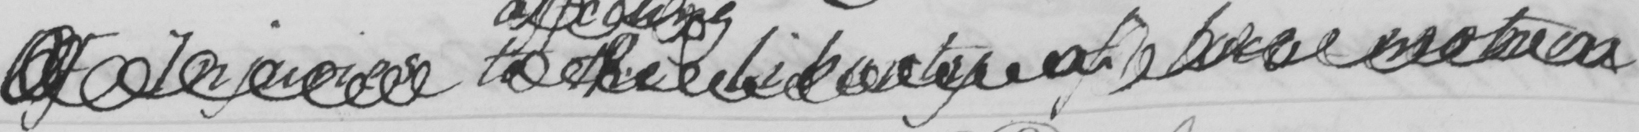Transcribe the text shown in this historical manuscript line. Of Injuries to the Liberty of Loco-Motion 